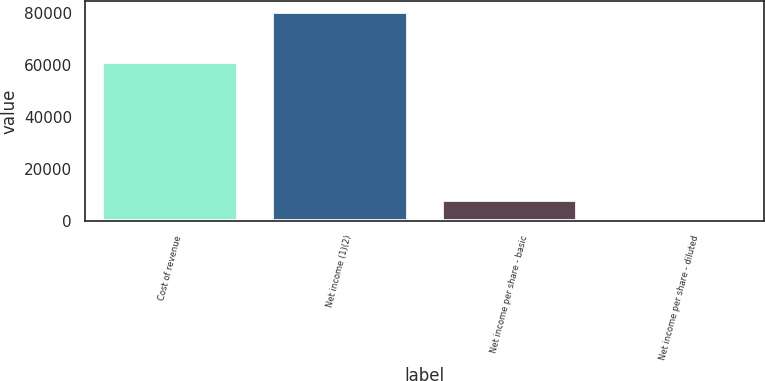Convert chart. <chart><loc_0><loc_0><loc_500><loc_500><bar_chart><fcel>Cost of revenue<fcel>Net income (1)(2)<fcel>Net income per share - basic<fcel>Net income per share - diluted<nl><fcel>60902<fcel>80374<fcel>8037.63<fcel>0.26<nl></chart> 